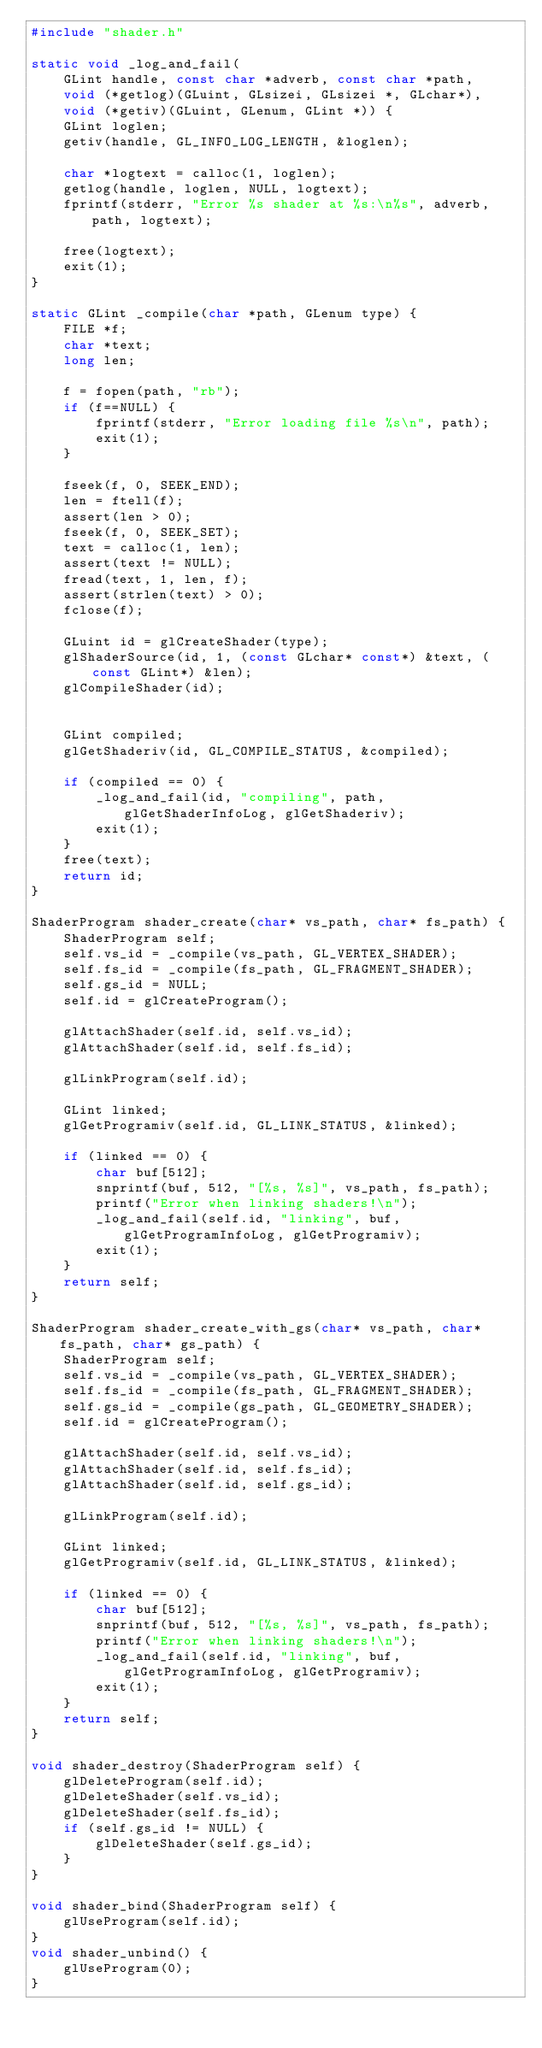Convert code to text. <code><loc_0><loc_0><loc_500><loc_500><_C_>#include "shader.h"

static void _log_and_fail(
    GLint handle, const char *adverb, const char *path,
    void (*getlog)(GLuint, GLsizei, GLsizei *, GLchar*),
    void (*getiv)(GLuint, GLenum, GLint *)) {
    GLint loglen;
    getiv(handle, GL_INFO_LOG_LENGTH, &loglen);

    char *logtext = calloc(1, loglen);
    getlog(handle, loglen, NULL, logtext);
    fprintf(stderr, "Error %s shader at %s:\n%s", adverb, path, logtext);

    free(logtext);
    exit(1);
}

static GLint _compile(char *path, GLenum type) {
    FILE *f;
    char *text;
    long len;

    f = fopen(path, "rb");
    if (f==NULL) {
        fprintf(stderr, "Error loading file %s\n", path);
        exit(1);
    }

    fseek(f, 0, SEEK_END);
    len = ftell(f);
    assert(len > 0);
    fseek(f, 0, SEEK_SET);
    text = calloc(1, len);
    assert(text != NULL);
    fread(text, 1, len, f);
    assert(strlen(text) > 0);
    fclose(f);

    GLuint id = glCreateShader(type);
    glShaderSource(id, 1, (const GLchar* const*) &text, (const GLint*) &len);
    glCompileShader(id);


    GLint compiled;
    glGetShaderiv(id, GL_COMPILE_STATUS, &compiled);

    if (compiled == 0) {
        _log_and_fail(id, "compiling", path, glGetShaderInfoLog, glGetShaderiv);
        exit(1);
    }
    free(text);
    return id;
}

ShaderProgram shader_create(char* vs_path, char* fs_path) {
    ShaderProgram self;
    self.vs_id = _compile(vs_path, GL_VERTEX_SHADER);
    self.fs_id = _compile(fs_path, GL_FRAGMENT_SHADER);
    self.gs_id = NULL;
    self.id = glCreateProgram();

    glAttachShader(self.id, self.vs_id);
    glAttachShader(self.id, self.fs_id);

    glLinkProgram(self.id);

    GLint linked;
    glGetProgramiv(self.id, GL_LINK_STATUS, &linked);

    if (linked == 0) {
        char buf[512];
        snprintf(buf, 512, "[%s, %s]", vs_path, fs_path);
        printf("Error when linking shaders!\n");
        _log_and_fail(self.id, "linking", buf, glGetProgramInfoLog, glGetProgramiv);
        exit(1);
    }
    return self;
} 

ShaderProgram shader_create_with_gs(char* vs_path, char* fs_path, char* gs_path) {
    ShaderProgram self;
    self.vs_id = _compile(vs_path, GL_VERTEX_SHADER);
    self.fs_id = _compile(fs_path, GL_FRAGMENT_SHADER);
    self.gs_id = _compile(gs_path, GL_GEOMETRY_SHADER);
    self.id = glCreateProgram();

    glAttachShader(self.id, self.vs_id);
    glAttachShader(self.id, self.fs_id);
    glAttachShader(self.id, self.gs_id);

    glLinkProgram(self.id);

    GLint linked;
    glGetProgramiv(self.id, GL_LINK_STATUS, &linked);

    if (linked == 0) {
        char buf[512];
        snprintf(buf, 512, "[%s, %s]", vs_path, fs_path);
        printf("Error when linking shaders!\n");
        _log_and_fail(self.id, "linking", buf, glGetProgramInfoLog, glGetProgramiv);
        exit(1);
    }
    return self;
} 

void shader_destroy(ShaderProgram self) {
    glDeleteProgram(self.id);
    glDeleteShader(self.vs_id);
    glDeleteShader(self.fs_id);
    if (self.gs_id != NULL) {
        glDeleteShader(self.gs_id);
    }
}

void shader_bind(ShaderProgram self) {
    glUseProgram(self.id);
}
void shader_unbind() {
    glUseProgram(0);
}</code> 